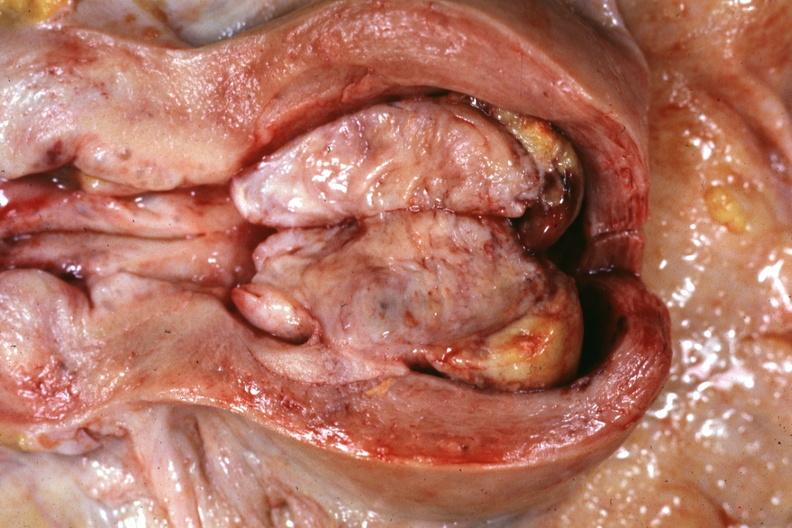does chromophobe adenoma show opened uterus with cut surface of tumor shown very good?
Answer the question using a single word or phrase. No 